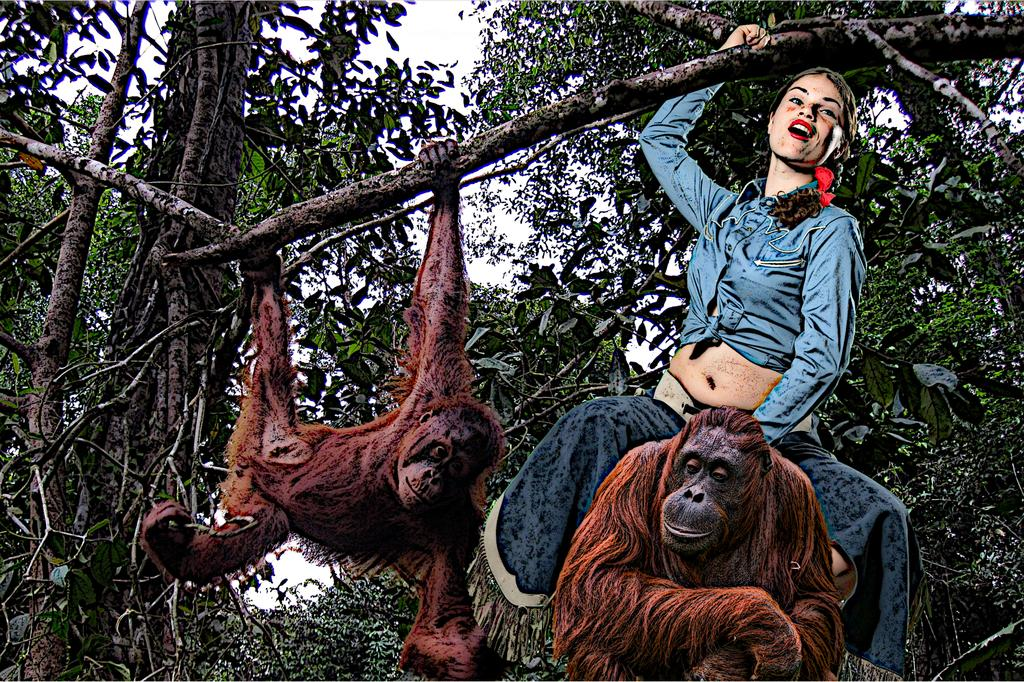Who is present in the image? There is a woman in the image. What other living beings can be seen in the image? There are two monkeys in the image. What can be seen in the background of the image? There are trees and sky visible in the background of the image. What is the woman holding in the image? The woman is holding a stick. What type of stamp can be seen on the woman's forehead in the image? There is no stamp visible on the woman's forehead in the image. 